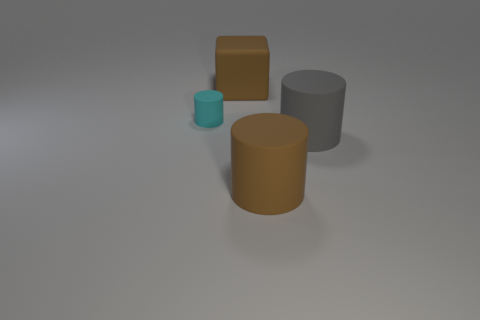Subtract all cyan cylinders. How many cylinders are left? 2 Add 1 brown metal cubes. How many objects exist? 5 Subtract all blocks. How many objects are left? 3 Subtract all small rubber cylinders. Subtract all large objects. How many objects are left? 0 Add 1 big brown rubber things. How many big brown rubber things are left? 3 Add 1 small cylinders. How many small cylinders exist? 2 Subtract 0 green spheres. How many objects are left? 4 Subtract all red cylinders. Subtract all purple blocks. How many cylinders are left? 3 